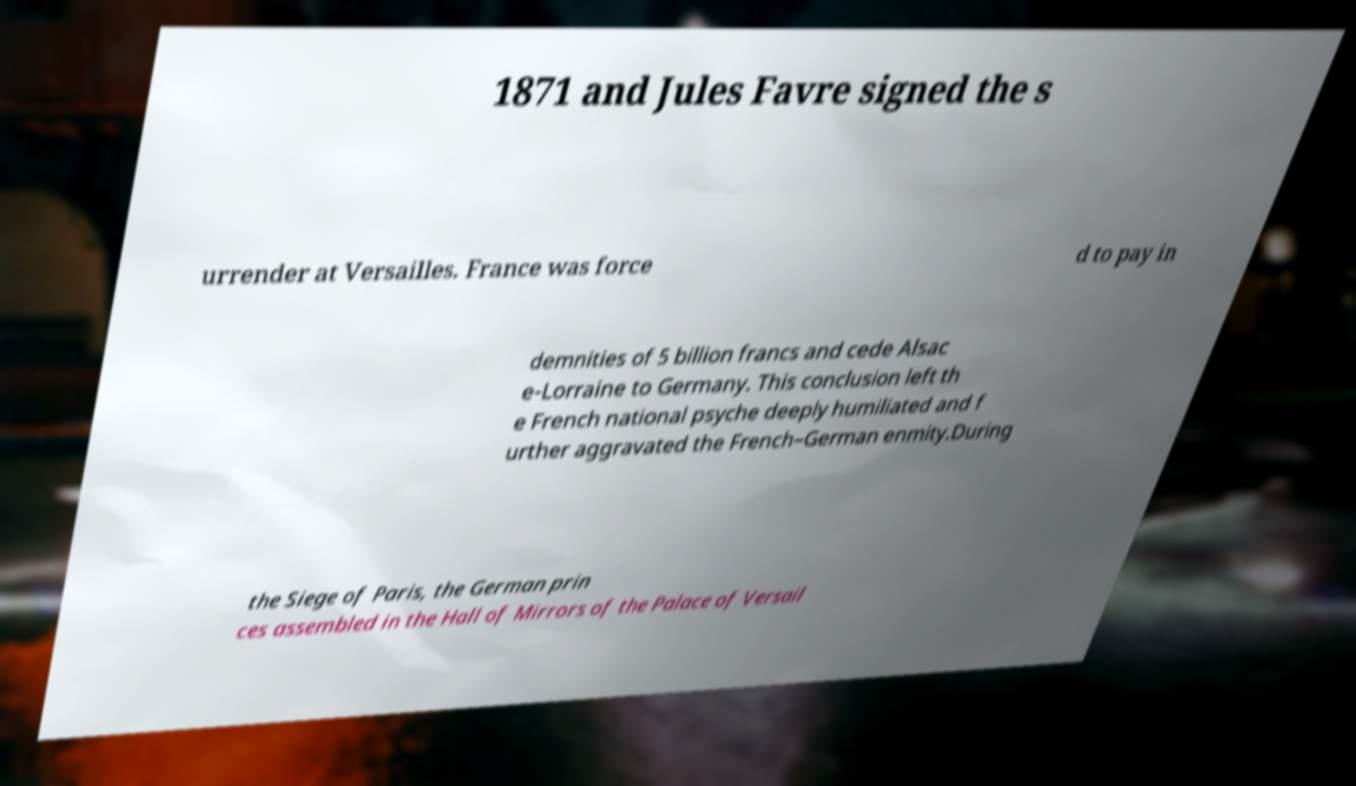Please read and relay the text visible in this image. What does it say? 1871 and Jules Favre signed the s urrender at Versailles. France was force d to pay in demnities of 5 billion francs and cede Alsac e-Lorraine to Germany. This conclusion left th e French national psyche deeply humiliated and f urther aggravated the French–German enmity.During the Siege of Paris, the German prin ces assembled in the Hall of Mirrors of the Palace of Versail 